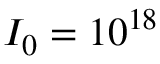Convert formula to latex. <formula><loc_0><loc_0><loc_500><loc_500>I _ { 0 } = 1 0 ^ { 1 8 }</formula> 